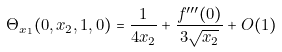Convert formula to latex. <formula><loc_0><loc_0><loc_500><loc_500>\Theta _ { x _ { 1 } } ( 0 , x _ { 2 } , 1 , 0 ) = \frac { 1 } { 4 x _ { 2 } } + \frac { f ^ { \prime \prime \prime } ( 0 ) } { 3 \sqrt { x _ { 2 } } } + O ( 1 )</formula> 